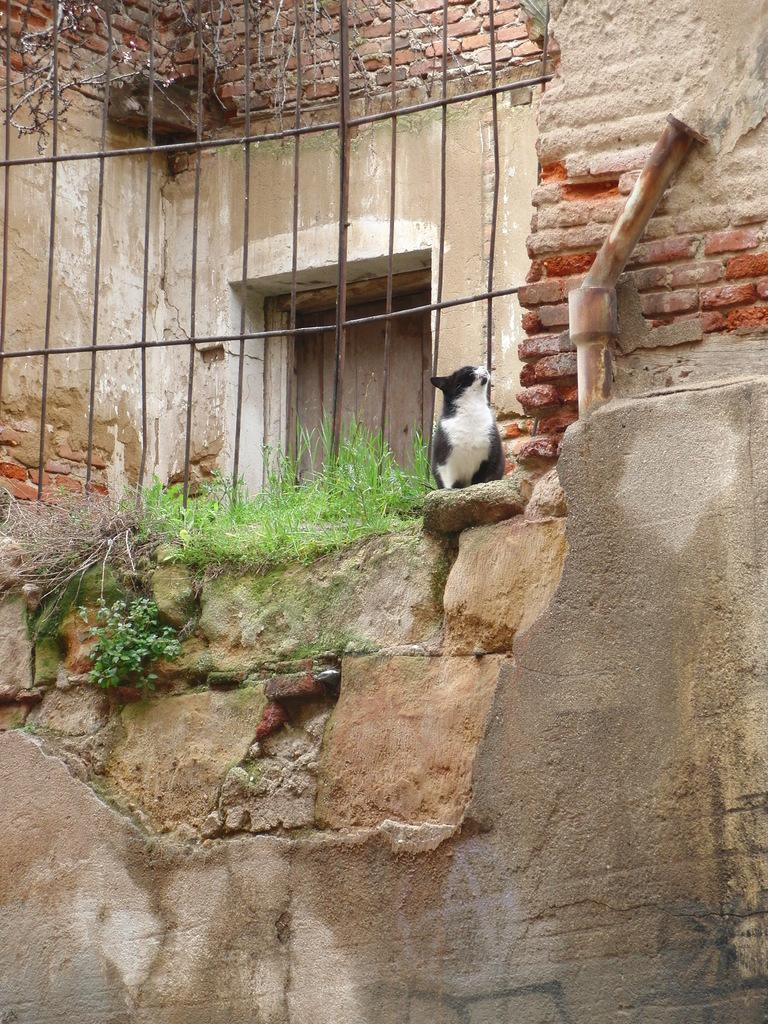What type of animal is in the image? There is a cat in the image. Where is the cat located? The cat is on the wall. What can be seen in the background of the image? There is a door, a building, and fencing in the background of the image. What type of suit is the sister wearing in the image? There is no sister or suit present in the image; it features a cat on the wall and background elements. 